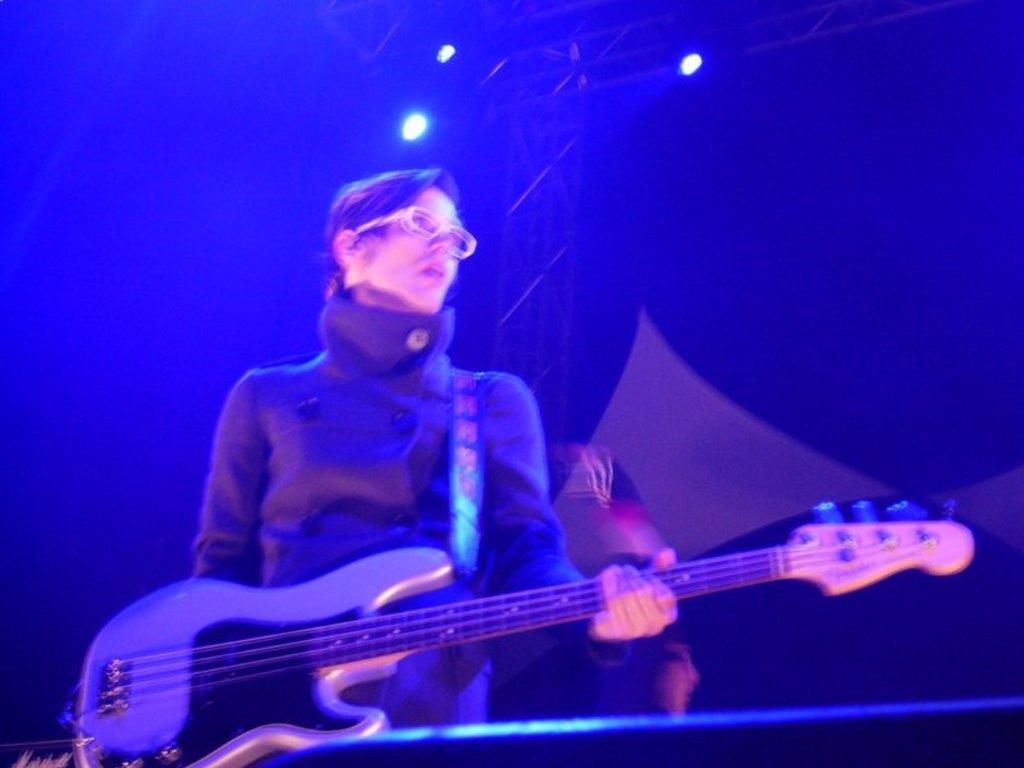In one or two sentences, can you explain what this image depicts? In this image there is a person standing and playing guitar. At the front there is a speaker, at the top there is a light. 